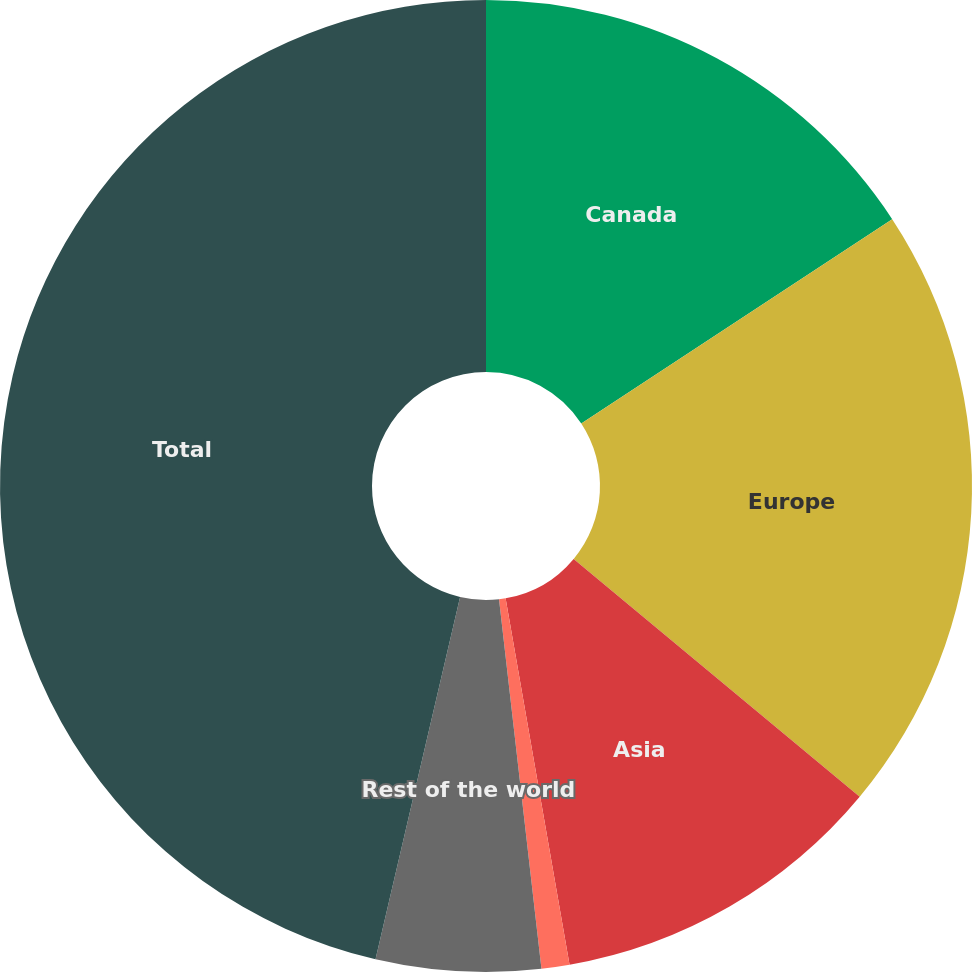Convert chart to OTSL. <chart><loc_0><loc_0><loc_500><loc_500><pie_chart><fcel>Canada<fcel>Europe<fcel>Asia<fcel>Middle East<fcel>Rest of the world<fcel>Total<nl><fcel>15.75%<fcel>20.29%<fcel>11.21%<fcel>0.93%<fcel>5.47%<fcel>46.35%<nl></chart> 